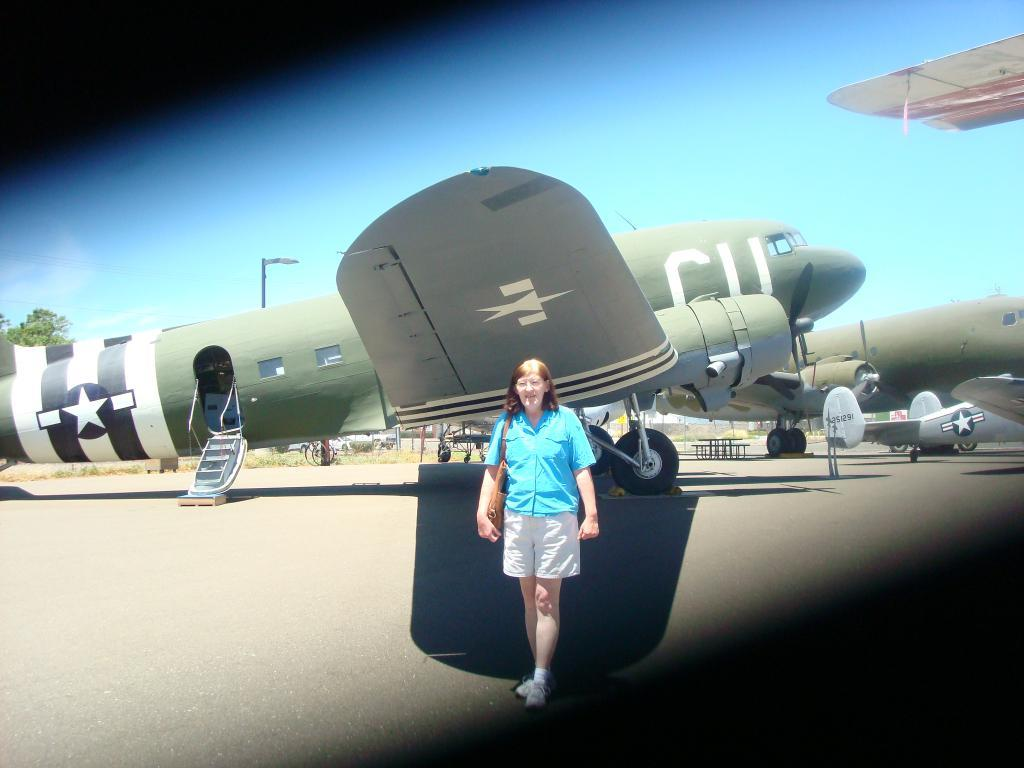Provide a one-sentence caption for the provided image. Star logo on a CU Airplane that is green. 